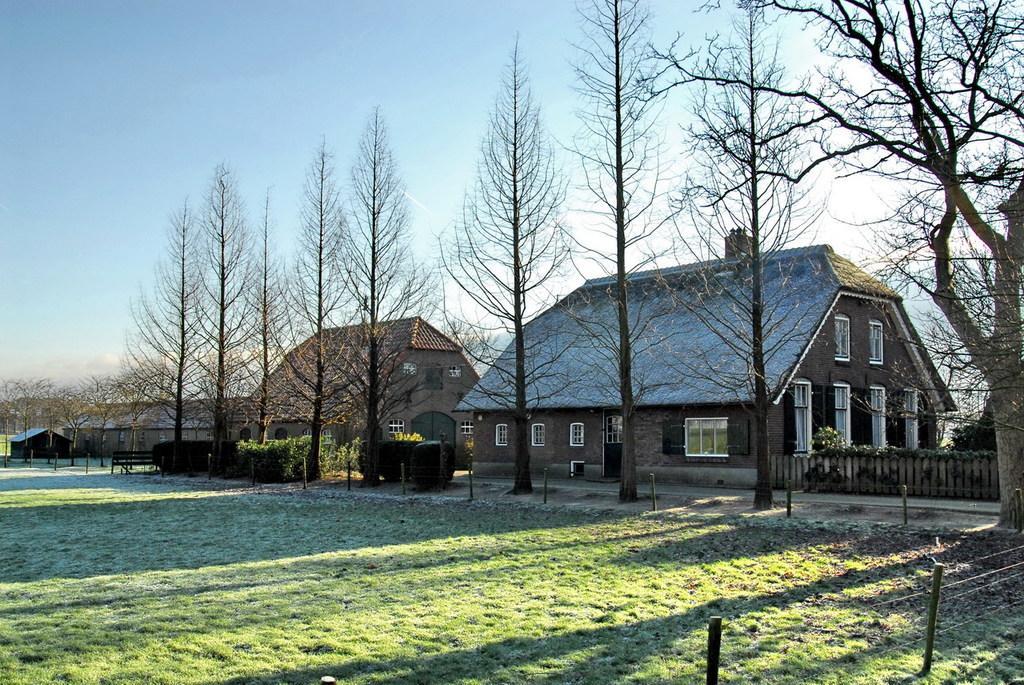How would you summarize this image in a sentence or two? In this picture we can see some houses, trees and grass, there is a clear sky. 